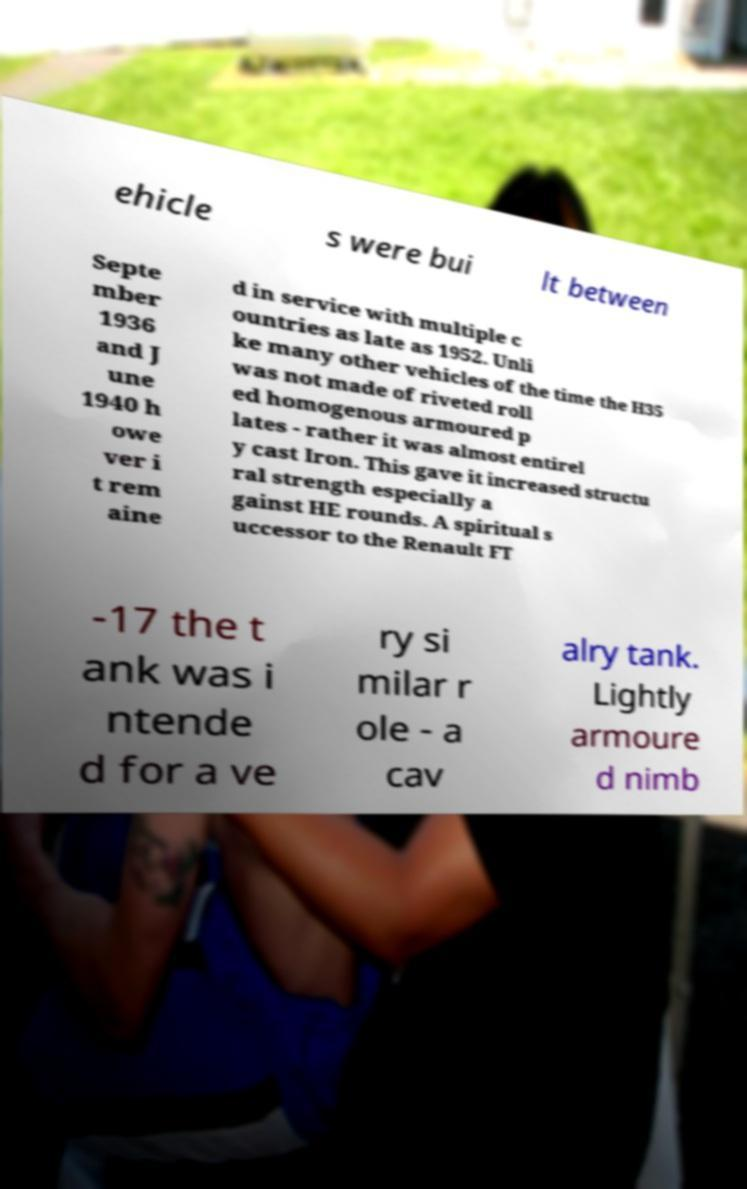For documentation purposes, I need the text within this image transcribed. Could you provide that? ehicle s were bui lt between Septe mber 1936 and J une 1940 h owe ver i t rem aine d in service with multiple c ountries as late as 1952. Unli ke many other vehicles of the time the H35 was not made of riveted roll ed homogenous armoured p lates - rather it was almost entirel y cast Iron. This gave it increased structu ral strength especially a gainst HE rounds. A spiritual s uccessor to the Renault FT -17 the t ank was i ntende d for a ve ry si milar r ole - a cav alry tank. Lightly armoure d nimb 